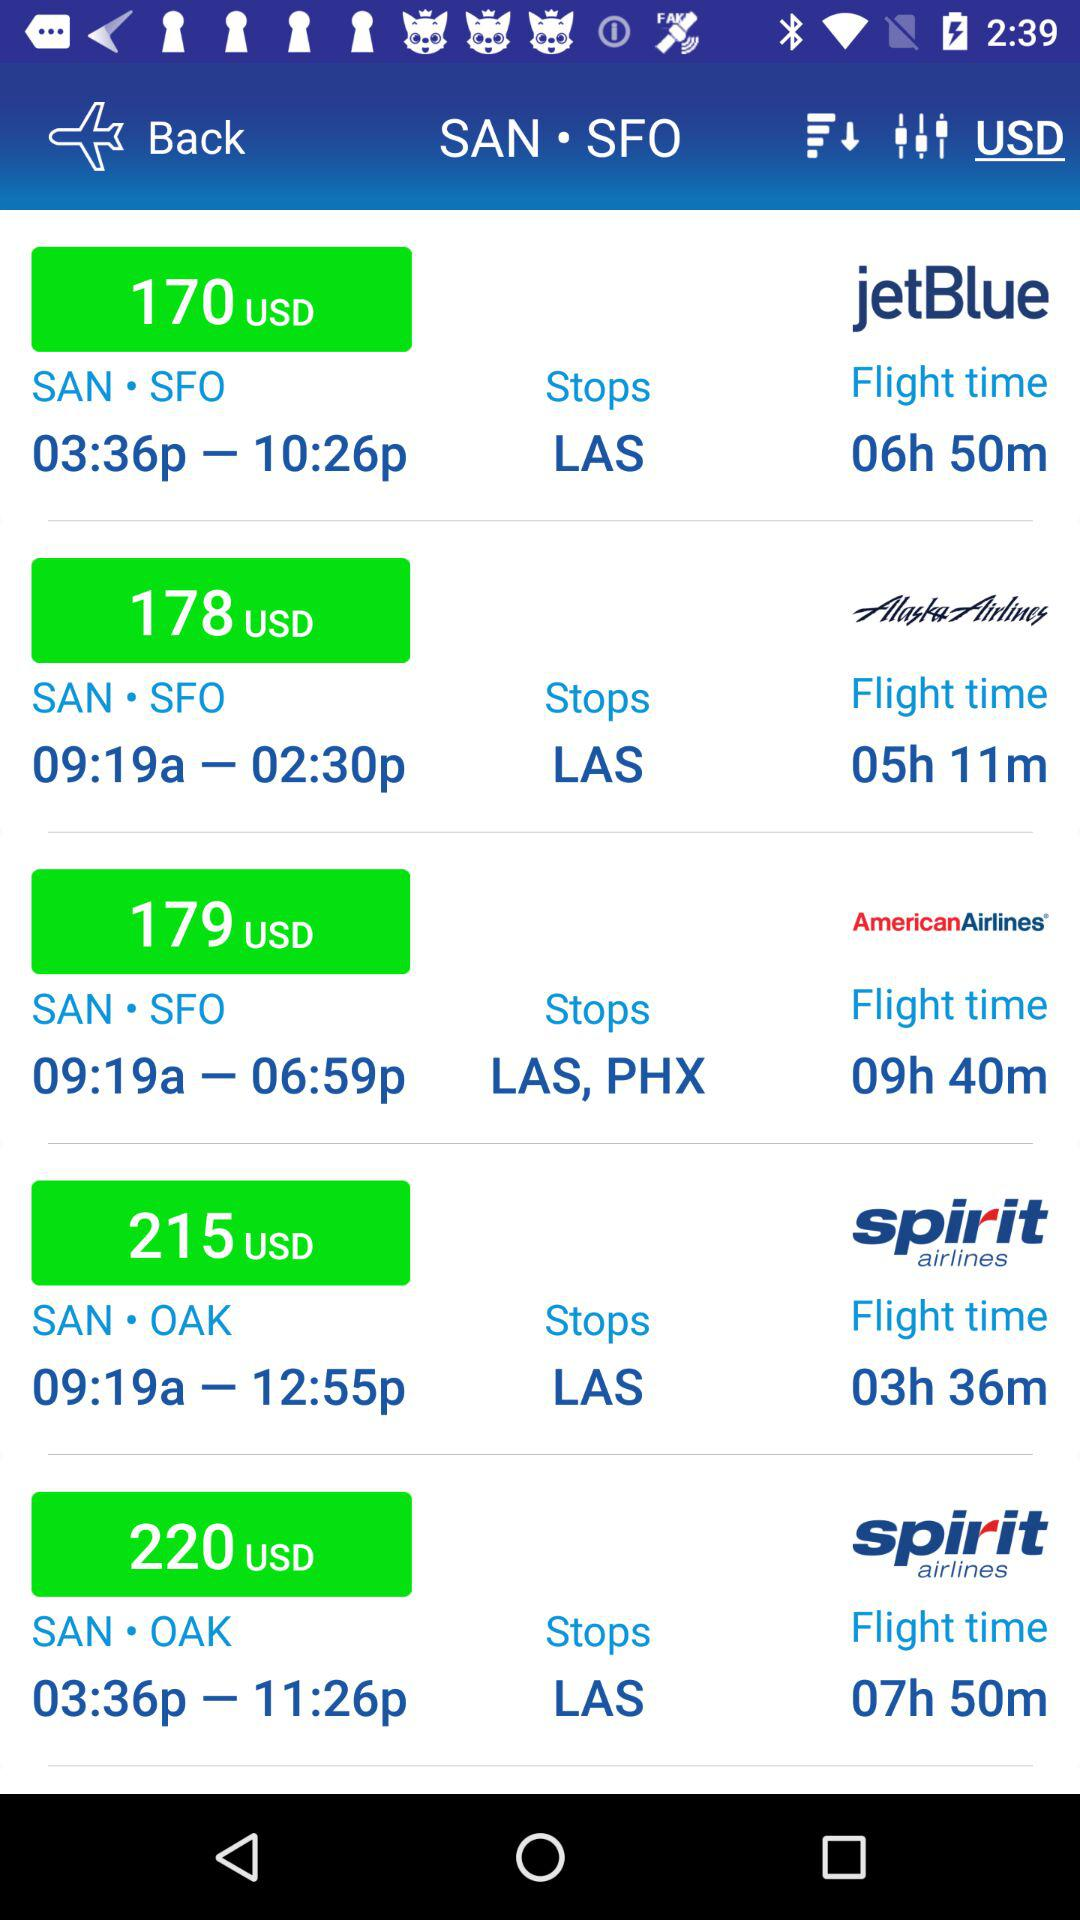What is the flight time of "Spirit Airlines"? The flight times are 3 hours 36 minutes and 7 hours 50 minutes. 